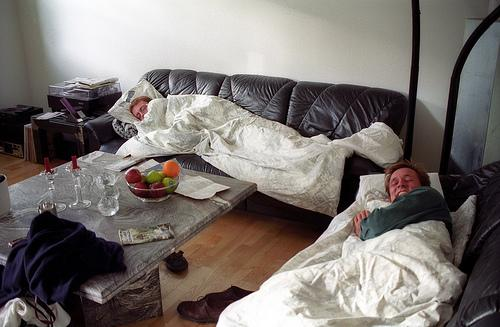List the items found on the coffee table. A bowl of fruit, two candlesticks, blue clothing, and glassware are on the coffee table. Describe any electronic devices seen in the image. A record player and stereo system are placed next to some records on a small table. Mention the color of one of the men's shirts and where his hand is resting. A man is wearing a green shirt and has his fingers resting on the sofa. Describe the setting and any background decor in the image. The living room has large black railings in the back, white walls, and brown wood flooring. Identify the items found on the floor of the image and their colors. A pair of shoes and one sandal are on the floor, along with blue clothing on a table. Mention the colors and materials of the main objects in the image. The living room has white walls, brown wood flooring, black leather couches, a glass bowl of fruit on the table, and red candles. Explain what the men are covered with and details about the couches. Both men are sleeping under white blankets on leather couches with noticeable lines and wrinkles in the material. Provide a general description of the scene in the image. Two men are sleeping on leather couches in a living room with a coffee table holding a bowl of fruit and candles, while shoes and clothes lie on the floor. Describe the position of the individuals and the main furniture piece in the image. Two men are lying on couches with their heads on pillows, near a coffee table in the center of the living room. State what type of fruit is in the glass bowl on the table. The glass bowl on the table has a mix of apples and oranges. 